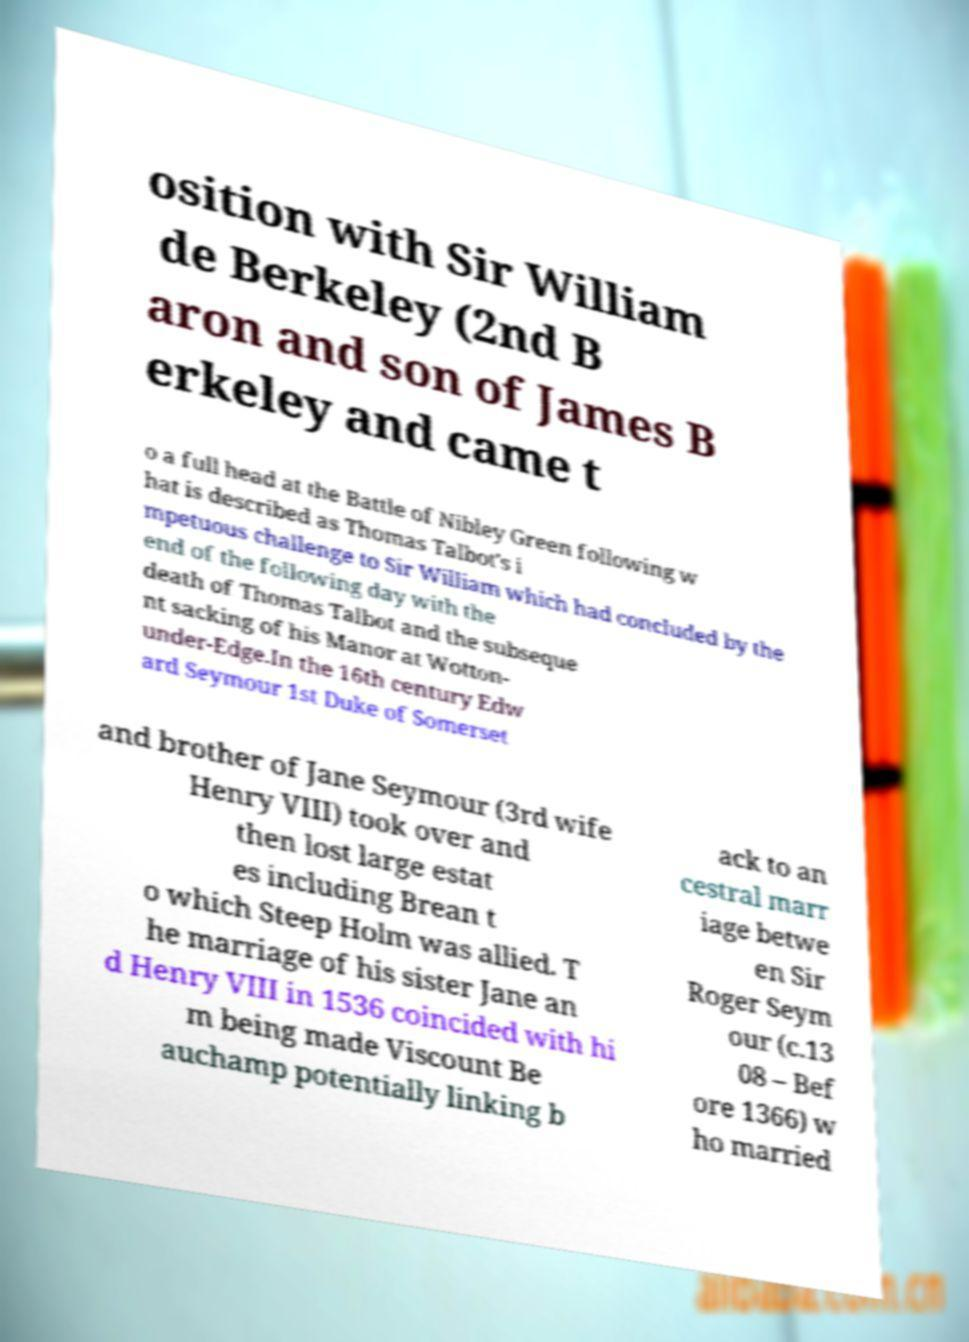Could you extract and type out the text from this image? osition with Sir William de Berkeley (2nd B aron and son of James B erkeley and came t o a full head at the Battle of Nibley Green following w hat is described as Thomas Talbot's i mpetuous challenge to Sir William which had concluded by the end of the following day with the death of Thomas Talbot and the subseque nt sacking of his Manor at Wotton- under-Edge.In the 16th century Edw ard Seymour 1st Duke of Somerset and brother of Jane Seymour (3rd wife Henry VIII) took over and then lost large estat es including Brean t o which Steep Holm was allied. T he marriage of his sister Jane an d Henry VIII in 1536 coincided with hi m being made Viscount Be auchamp potentially linking b ack to an cestral marr iage betwe en Sir Roger Seym our (c.13 08 – Bef ore 1366) w ho married 